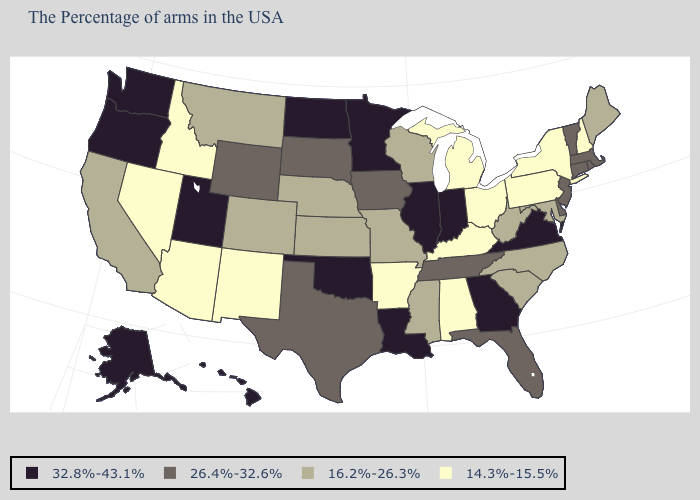Name the states that have a value in the range 32.8%-43.1%?
Be succinct. Virginia, Georgia, Indiana, Illinois, Louisiana, Minnesota, Oklahoma, North Dakota, Utah, Washington, Oregon, Alaska, Hawaii. Does the first symbol in the legend represent the smallest category?
Keep it brief. No. Among the states that border New York , does Massachusetts have the highest value?
Give a very brief answer. Yes. What is the value of Iowa?
Be succinct. 26.4%-32.6%. Among the states that border North Carolina , does South Carolina have the lowest value?
Answer briefly. Yes. What is the value of Connecticut?
Short answer required. 26.4%-32.6%. What is the highest value in states that border Vermont?
Keep it brief. 26.4%-32.6%. Does the first symbol in the legend represent the smallest category?
Short answer required. No. Name the states that have a value in the range 26.4%-32.6%?
Give a very brief answer. Massachusetts, Rhode Island, Vermont, Connecticut, New Jersey, Delaware, Florida, Tennessee, Iowa, Texas, South Dakota, Wyoming. Does the map have missing data?
Keep it brief. No. Name the states that have a value in the range 14.3%-15.5%?
Be succinct. New Hampshire, New York, Pennsylvania, Ohio, Michigan, Kentucky, Alabama, Arkansas, New Mexico, Arizona, Idaho, Nevada. Among the states that border Kentucky , does Illinois have the lowest value?
Quick response, please. No. Does West Virginia have the same value as California?
Keep it brief. Yes. Name the states that have a value in the range 16.2%-26.3%?
Give a very brief answer. Maine, Maryland, North Carolina, South Carolina, West Virginia, Wisconsin, Mississippi, Missouri, Kansas, Nebraska, Colorado, Montana, California. What is the value of Louisiana?
Answer briefly. 32.8%-43.1%. 